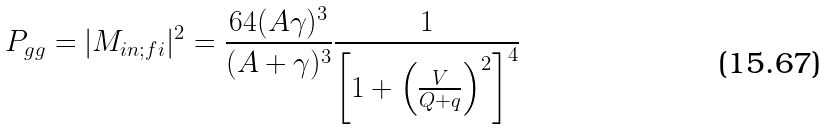Convert formula to latex. <formula><loc_0><loc_0><loc_500><loc_500>P _ { g g } = | M _ { i n ; f i } | ^ { 2 } = \frac { 6 4 ( A \gamma ) ^ { 3 } } { ( A + \gamma ) ^ { 3 } } \frac { 1 } { \left [ 1 + \left ( \frac { V } { Q + q } \right ) ^ { 2 } \right ] ^ { 4 } }</formula> 